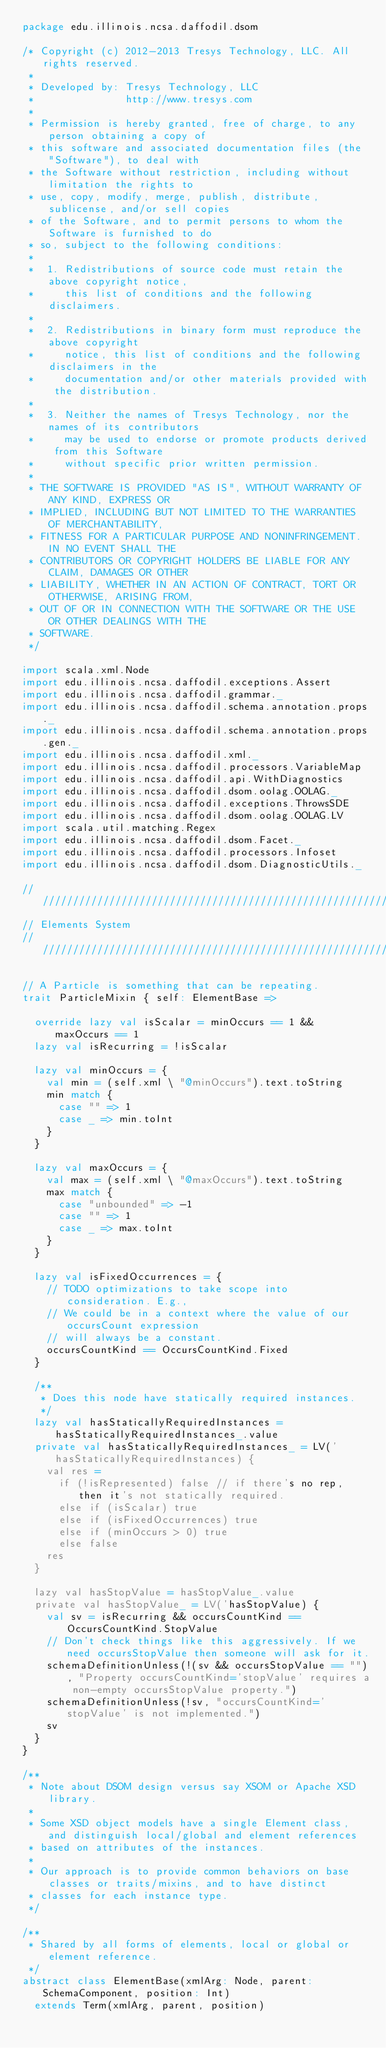<code> <loc_0><loc_0><loc_500><loc_500><_Scala_>package edu.illinois.ncsa.daffodil.dsom

/* Copyright (c) 2012-2013 Tresys Technology, LLC. All rights reserved.
 *
 * Developed by: Tresys Technology, LLC
 *               http://www.tresys.com
 * 
 * Permission is hereby granted, free of charge, to any person obtaining a copy of
 * this software and associated documentation files (the "Software"), to deal with
 * the Software without restriction, including without limitation the rights to
 * use, copy, modify, merge, publish, distribute, sublicense, and/or sell copies
 * of the Software, and to permit persons to whom the Software is furnished to do
 * so, subject to the following conditions:
 * 
 *  1. Redistributions of source code must retain the above copyright notice,
 *     this list of conditions and the following disclaimers.
 * 
 *  2. Redistributions in binary form must reproduce the above copyright
 *     notice, this list of conditions and the following disclaimers in the
 *     documentation and/or other materials provided with the distribution.
 * 
 *  3. Neither the names of Tresys Technology, nor the names of its contributors
 *     may be used to endorse or promote products derived from this Software
 *     without specific prior written permission.
 * 
 * THE SOFTWARE IS PROVIDED "AS IS", WITHOUT WARRANTY OF ANY KIND, EXPRESS OR
 * IMPLIED, INCLUDING BUT NOT LIMITED TO THE WARRANTIES OF MERCHANTABILITY,
 * FITNESS FOR A PARTICULAR PURPOSE AND NONINFRINGEMENT. IN NO EVENT SHALL THE
 * CONTRIBUTORS OR COPYRIGHT HOLDERS BE LIABLE FOR ANY CLAIM, DAMAGES OR OTHER
 * LIABILITY, WHETHER IN AN ACTION OF CONTRACT, TORT OR OTHERWISE, ARISING FROM,
 * OUT OF OR IN CONNECTION WITH THE SOFTWARE OR THE USE OR OTHER DEALINGS WITH THE
 * SOFTWARE.
 */

import scala.xml.Node
import edu.illinois.ncsa.daffodil.exceptions.Assert
import edu.illinois.ncsa.daffodil.grammar._
import edu.illinois.ncsa.daffodil.schema.annotation.props._
import edu.illinois.ncsa.daffodil.schema.annotation.props.gen._
import edu.illinois.ncsa.daffodil.xml._
import edu.illinois.ncsa.daffodil.processors.VariableMap
import edu.illinois.ncsa.daffodil.api.WithDiagnostics
import edu.illinois.ncsa.daffodil.dsom.oolag.OOLAG._
import edu.illinois.ncsa.daffodil.exceptions.ThrowsSDE
import edu.illinois.ncsa.daffodil.dsom.oolag.OOLAG.LV
import scala.util.matching.Regex
import edu.illinois.ncsa.daffodil.dsom.Facet._
import edu.illinois.ncsa.daffodil.processors.Infoset
import edu.illinois.ncsa.daffodil.dsom.DiagnosticUtils._

/////////////////////////////////////////////////////////////////
// Elements System
/////////////////////////////////////////////////////////////////

// A Particle is something that can be repeating.
trait ParticleMixin { self: ElementBase =>

  override lazy val isScalar = minOccurs == 1 && maxOccurs == 1
  lazy val isRecurring = !isScalar

  lazy val minOccurs = {
    val min = (self.xml \ "@minOccurs").text.toString
    min match {
      case "" => 1
      case _ => min.toInt
    }
  }

  lazy val maxOccurs = {
    val max = (self.xml \ "@maxOccurs").text.toString
    max match {
      case "unbounded" => -1
      case "" => 1
      case _ => max.toInt
    }
  }

  lazy val isFixedOccurrences = {
    // TODO optimizations to take scope into consideration. E.g.,
    // We could be in a context where the value of our occursCount expression
    // will always be a constant. 
    occursCountKind == OccursCountKind.Fixed
  }

  /**
   * Does this node have statically required instances.
   */
  lazy val hasStaticallyRequiredInstances = hasStaticallyRequiredInstances_.value
  private val hasStaticallyRequiredInstances_ = LV('hasStaticallyRequiredInstances) {
    val res =
      if (!isRepresented) false // if there's no rep, then it's not statically required.
      else if (isScalar) true
      else if (isFixedOccurrences) true
      else if (minOccurs > 0) true
      else false
    res
  }

  lazy val hasStopValue = hasStopValue_.value
  private val hasStopValue_ = LV('hasStopValue) {
    val sv = isRecurring && occursCountKind == OccursCountKind.StopValue
    // Don't check things like this aggressively. If we need occursStopValue then someone will ask for it.
    schemaDefinitionUnless(!(sv && occursStopValue == ""), "Property occursCountKind='stopValue' requires a non-empty occursStopValue property.")
    schemaDefinitionUnless(!sv, "occursCountKind='stopValue' is not implemented.")
    sv
  }
}

/**
 * Note about DSOM design versus say XSOM or Apache XSD library.
 *
 * Some XSD object models have a single Element class, and distinguish local/global and element references
 * based on attributes of the instances.
 *
 * Our approach is to provide common behaviors on base classes or traits/mixins, and to have distinct
 * classes for each instance type.
 */

/**
 * Shared by all forms of elements, local or global or element reference.
 */
abstract class ElementBase(xmlArg: Node, parent: SchemaComponent, position: Int)
  extends Term(xmlArg, parent, position)</code> 